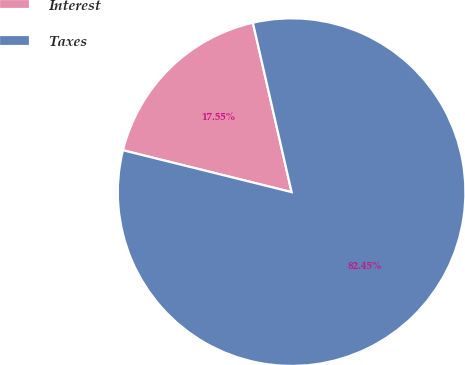Convert chart. <chart><loc_0><loc_0><loc_500><loc_500><pie_chart><fcel>Interest<fcel>Taxes<nl><fcel>17.55%<fcel>82.45%<nl></chart> 